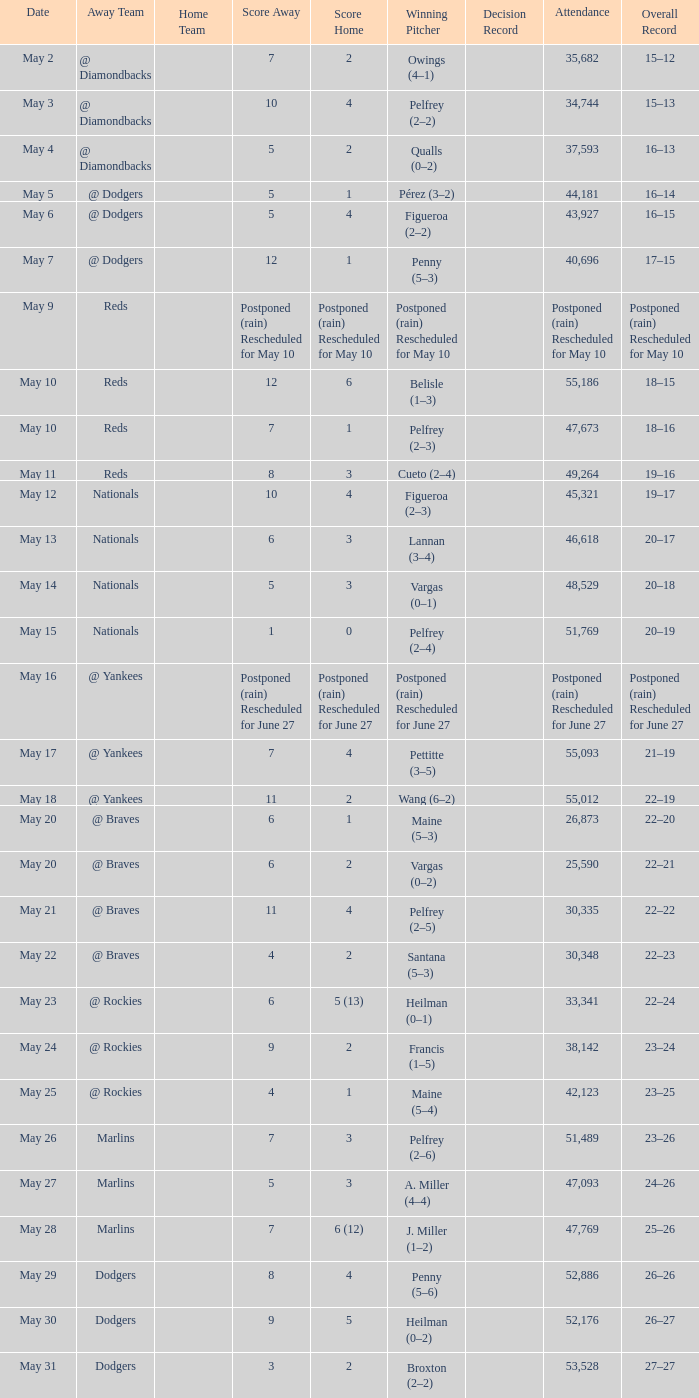Record of 19–16 occurred on what date? May 11. 